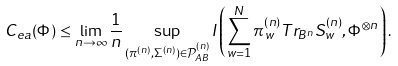Convert formula to latex. <formula><loc_0><loc_0><loc_500><loc_500>C _ { e a } ( \Phi ) \leq \lim _ { n \rightarrow \infty } \frac { 1 } { n } \sup _ { ( \pi ^ { ( n ) } , \Sigma ^ { ( n ) } ) \in \mathcal { P } _ { A B } ^ { ( n ) } } I \left ( \sum _ { w = 1 } ^ { N } \pi _ { w } ^ { ( n ) } T r _ { B ^ { n } } S _ { w } ^ { ( n ) } , \Phi ^ { \otimes n } \right ) .</formula> 